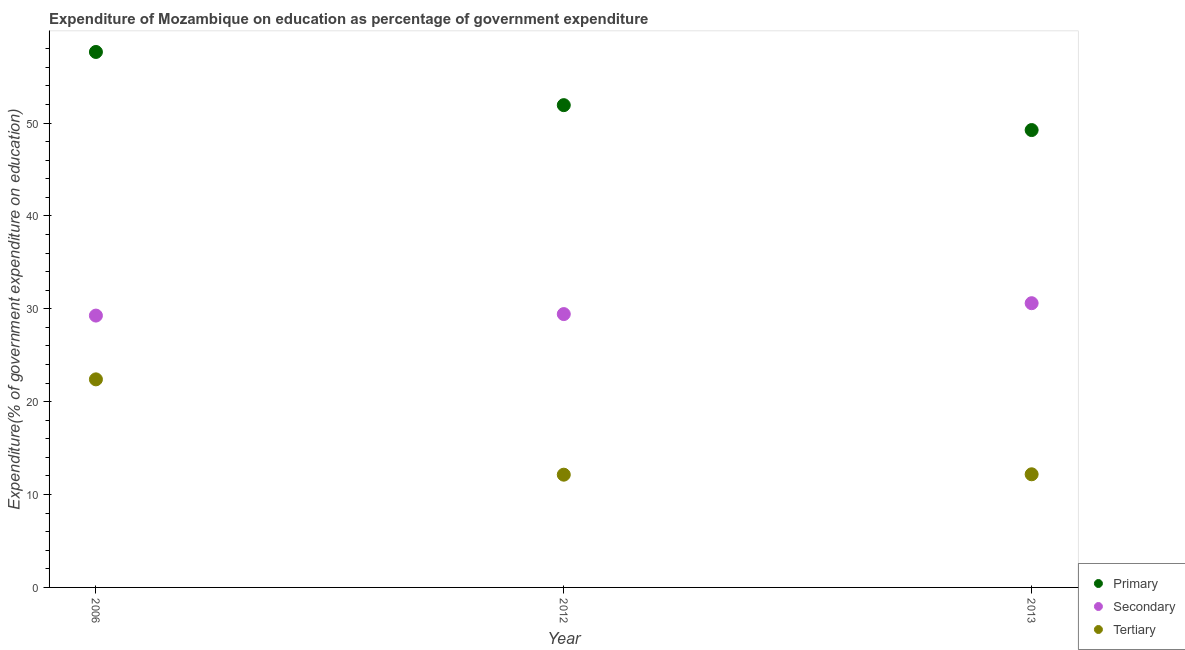Is the number of dotlines equal to the number of legend labels?
Provide a short and direct response. Yes. What is the expenditure on primary education in 2013?
Offer a very short reply. 49.25. Across all years, what is the maximum expenditure on primary education?
Your response must be concise. 57.66. Across all years, what is the minimum expenditure on tertiary education?
Offer a very short reply. 12.14. In which year was the expenditure on primary education minimum?
Offer a terse response. 2013. What is the total expenditure on tertiary education in the graph?
Your answer should be compact. 46.73. What is the difference between the expenditure on primary education in 2012 and that in 2013?
Keep it short and to the point. 2.68. What is the difference between the expenditure on secondary education in 2006 and the expenditure on tertiary education in 2012?
Your answer should be compact. 17.13. What is the average expenditure on primary education per year?
Give a very brief answer. 52.94. In the year 2006, what is the difference between the expenditure on primary education and expenditure on tertiary education?
Keep it short and to the point. 35.25. What is the ratio of the expenditure on secondary education in 2006 to that in 2012?
Provide a succinct answer. 0.99. Is the expenditure on primary education in 2012 less than that in 2013?
Offer a very short reply. No. Is the difference between the expenditure on tertiary education in 2012 and 2013 greater than the difference between the expenditure on secondary education in 2012 and 2013?
Ensure brevity in your answer.  Yes. What is the difference between the highest and the second highest expenditure on primary education?
Provide a short and direct response. 5.73. What is the difference between the highest and the lowest expenditure on tertiary education?
Offer a very short reply. 10.26. Does the expenditure on secondary education monotonically increase over the years?
Give a very brief answer. Yes. Is the expenditure on tertiary education strictly greater than the expenditure on primary education over the years?
Provide a succinct answer. No. How many dotlines are there?
Ensure brevity in your answer.  3. How many years are there in the graph?
Offer a terse response. 3. Where does the legend appear in the graph?
Make the answer very short. Bottom right. How many legend labels are there?
Keep it short and to the point. 3. How are the legend labels stacked?
Give a very brief answer. Vertical. What is the title of the graph?
Your answer should be compact. Expenditure of Mozambique on education as percentage of government expenditure. What is the label or title of the X-axis?
Your response must be concise. Year. What is the label or title of the Y-axis?
Your response must be concise. Expenditure(% of government expenditure on education). What is the Expenditure(% of government expenditure on education) in Primary in 2006?
Give a very brief answer. 57.66. What is the Expenditure(% of government expenditure on education) of Secondary in 2006?
Offer a very short reply. 29.27. What is the Expenditure(% of government expenditure on education) in Tertiary in 2006?
Your answer should be compact. 22.4. What is the Expenditure(% of government expenditure on education) in Primary in 2012?
Offer a terse response. 51.93. What is the Expenditure(% of government expenditure on education) in Secondary in 2012?
Give a very brief answer. 29.43. What is the Expenditure(% of government expenditure on education) in Tertiary in 2012?
Make the answer very short. 12.14. What is the Expenditure(% of government expenditure on education) in Primary in 2013?
Offer a terse response. 49.25. What is the Expenditure(% of government expenditure on education) in Secondary in 2013?
Your response must be concise. 30.6. What is the Expenditure(% of government expenditure on education) of Tertiary in 2013?
Your answer should be very brief. 12.18. Across all years, what is the maximum Expenditure(% of government expenditure on education) in Primary?
Give a very brief answer. 57.66. Across all years, what is the maximum Expenditure(% of government expenditure on education) of Secondary?
Your answer should be very brief. 30.6. Across all years, what is the maximum Expenditure(% of government expenditure on education) in Tertiary?
Give a very brief answer. 22.4. Across all years, what is the minimum Expenditure(% of government expenditure on education) of Primary?
Offer a terse response. 49.25. Across all years, what is the minimum Expenditure(% of government expenditure on education) of Secondary?
Keep it short and to the point. 29.27. Across all years, what is the minimum Expenditure(% of government expenditure on education) of Tertiary?
Ensure brevity in your answer.  12.14. What is the total Expenditure(% of government expenditure on education) in Primary in the graph?
Keep it short and to the point. 158.83. What is the total Expenditure(% of government expenditure on education) of Secondary in the graph?
Your answer should be very brief. 89.31. What is the total Expenditure(% of government expenditure on education) of Tertiary in the graph?
Offer a very short reply. 46.73. What is the difference between the Expenditure(% of government expenditure on education) in Primary in 2006 and that in 2012?
Your response must be concise. 5.73. What is the difference between the Expenditure(% of government expenditure on education) in Secondary in 2006 and that in 2012?
Your answer should be compact. -0.16. What is the difference between the Expenditure(% of government expenditure on education) in Tertiary in 2006 and that in 2012?
Keep it short and to the point. 10.26. What is the difference between the Expenditure(% of government expenditure on education) in Primary in 2006 and that in 2013?
Your answer should be compact. 8.41. What is the difference between the Expenditure(% of government expenditure on education) of Secondary in 2006 and that in 2013?
Provide a succinct answer. -1.33. What is the difference between the Expenditure(% of government expenditure on education) in Tertiary in 2006 and that in 2013?
Make the answer very short. 10.22. What is the difference between the Expenditure(% of government expenditure on education) in Primary in 2012 and that in 2013?
Keep it short and to the point. 2.68. What is the difference between the Expenditure(% of government expenditure on education) of Secondary in 2012 and that in 2013?
Keep it short and to the point. -1.17. What is the difference between the Expenditure(% of government expenditure on education) in Tertiary in 2012 and that in 2013?
Offer a very short reply. -0.04. What is the difference between the Expenditure(% of government expenditure on education) in Primary in 2006 and the Expenditure(% of government expenditure on education) in Secondary in 2012?
Provide a succinct answer. 28.22. What is the difference between the Expenditure(% of government expenditure on education) in Primary in 2006 and the Expenditure(% of government expenditure on education) in Tertiary in 2012?
Offer a very short reply. 45.52. What is the difference between the Expenditure(% of government expenditure on education) in Secondary in 2006 and the Expenditure(% of government expenditure on education) in Tertiary in 2012?
Keep it short and to the point. 17.13. What is the difference between the Expenditure(% of government expenditure on education) in Primary in 2006 and the Expenditure(% of government expenditure on education) in Secondary in 2013?
Offer a terse response. 27.05. What is the difference between the Expenditure(% of government expenditure on education) of Primary in 2006 and the Expenditure(% of government expenditure on education) of Tertiary in 2013?
Provide a succinct answer. 45.47. What is the difference between the Expenditure(% of government expenditure on education) of Secondary in 2006 and the Expenditure(% of government expenditure on education) of Tertiary in 2013?
Your answer should be very brief. 17.09. What is the difference between the Expenditure(% of government expenditure on education) of Primary in 2012 and the Expenditure(% of government expenditure on education) of Secondary in 2013?
Your answer should be compact. 21.33. What is the difference between the Expenditure(% of government expenditure on education) in Primary in 2012 and the Expenditure(% of government expenditure on education) in Tertiary in 2013?
Offer a terse response. 39.75. What is the difference between the Expenditure(% of government expenditure on education) of Secondary in 2012 and the Expenditure(% of government expenditure on education) of Tertiary in 2013?
Your answer should be compact. 17.25. What is the average Expenditure(% of government expenditure on education) in Primary per year?
Your answer should be very brief. 52.94. What is the average Expenditure(% of government expenditure on education) of Secondary per year?
Ensure brevity in your answer.  29.77. What is the average Expenditure(% of government expenditure on education) in Tertiary per year?
Your answer should be compact. 15.58. In the year 2006, what is the difference between the Expenditure(% of government expenditure on education) of Primary and Expenditure(% of government expenditure on education) of Secondary?
Give a very brief answer. 28.39. In the year 2006, what is the difference between the Expenditure(% of government expenditure on education) in Primary and Expenditure(% of government expenditure on education) in Tertiary?
Your answer should be very brief. 35.25. In the year 2006, what is the difference between the Expenditure(% of government expenditure on education) of Secondary and Expenditure(% of government expenditure on education) of Tertiary?
Keep it short and to the point. 6.87. In the year 2012, what is the difference between the Expenditure(% of government expenditure on education) of Primary and Expenditure(% of government expenditure on education) of Secondary?
Your answer should be very brief. 22.5. In the year 2012, what is the difference between the Expenditure(% of government expenditure on education) in Primary and Expenditure(% of government expenditure on education) in Tertiary?
Keep it short and to the point. 39.79. In the year 2012, what is the difference between the Expenditure(% of government expenditure on education) of Secondary and Expenditure(% of government expenditure on education) of Tertiary?
Give a very brief answer. 17.29. In the year 2013, what is the difference between the Expenditure(% of government expenditure on education) of Primary and Expenditure(% of government expenditure on education) of Secondary?
Your response must be concise. 18.64. In the year 2013, what is the difference between the Expenditure(% of government expenditure on education) of Primary and Expenditure(% of government expenditure on education) of Tertiary?
Your answer should be very brief. 37.07. In the year 2013, what is the difference between the Expenditure(% of government expenditure on education) of Secondary and Expenditure(% of government expenditure on education) of Tertiary?
Provide a succinct answer. 18.42. What is the ratio of the Expenditure(% of government expenditure on education) of Primary in 2006 to that in 2012?
Make the answer very short. 1.11. What is the ratio of the Expenditure(% of government expenditure on education) in Secondary in 2006 to that in 2012?
Offer a terse response. 0.99. What is the ratio of the Expenditure(% of government expenditure on education) of Tertiary in 2006 to that in 2012?
Your answer should be very brief. 1.85. What is the ratio of the Expenditure(% of government expenditure on education) of Primary in 2006 to that in 2013?
Your answer should be compact. 1.17. What is the ratio of the Expenditure(% of government expenditure on education) in Secondary in 2006 to that in 2013?
Your response must be concise. 0.96. What is the ratio of the Expenditure(% of government expenditure on education) in Tertiary in 2006 to that in 2013?
Your answer should be compact. 1.84. What is the ratio of the Expenditure(% of government expenditure on education) of Primary in 2012 to that in 2013?
Give a very brief answer. 1.05. What is the ratio of the Expenditure(% of government expenditure on education) of Secondary in 2012 to that in 2013?
Your answer should be compact. 0.96. What is the difference between the highest and the second highest Expenditure(% of government expenditure on education) in Primary?
Your response must be concise. 5.73. What is the difference between the highest and the second highest Expenditure(% of government expenditure on education) in Secondary?
Provide a short and direct response. 1.17. What is the difference between the highest and the second highest Expenditure(% of government expenditure on education) in Tertiary?
Provide a succinct answer. 10.22. What is the difference between the highest and the lowest Expenditure(% of government expenditure on education) of Primary?
Provide a short and direct response. 8.41. What is the difference between the highest and the lowest Expenditure(% of government expenditure on education) in Secondary?
Give a very brief answer. 1.33. What is the difference between the highest and the lowest Expenditure(% of government expenditure on education) of Tertiary?
Give a very brief answer. 10.26. 